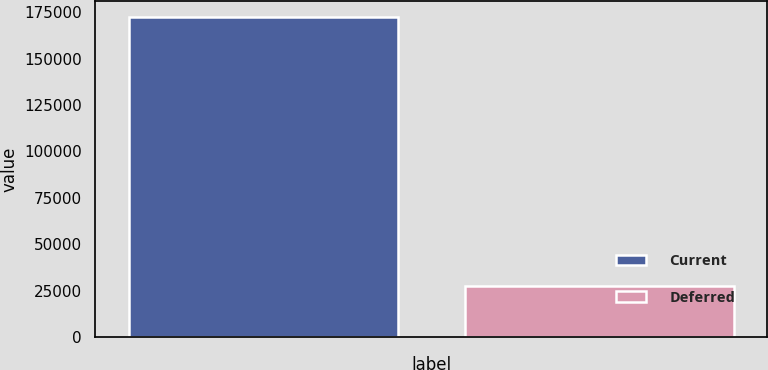<chart> <loc_0><loc_0><loc_500><loc_500><bar_chart><fcel>Current<fcel>Deferred<nl><fcel>172380<fcel>27463<nl></chart> 